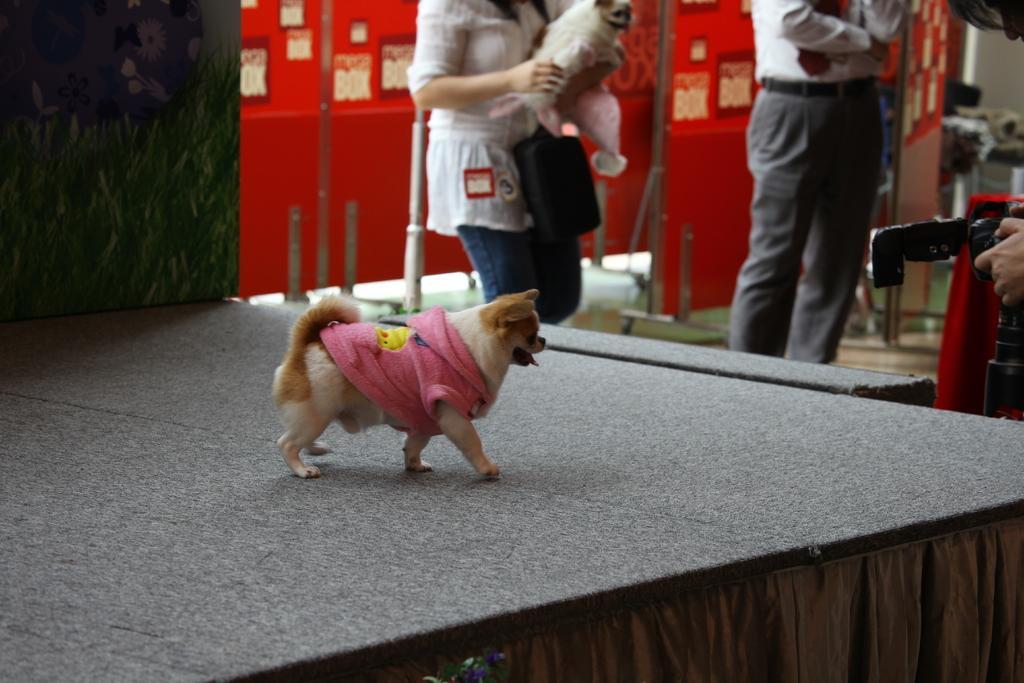Can you describe this image briefly? In this picture there is a dog walking. At the back there is a person standing and holding the dog and there is a person standing and there is a person standing and holding the camera. At the back there is a hoarding. 